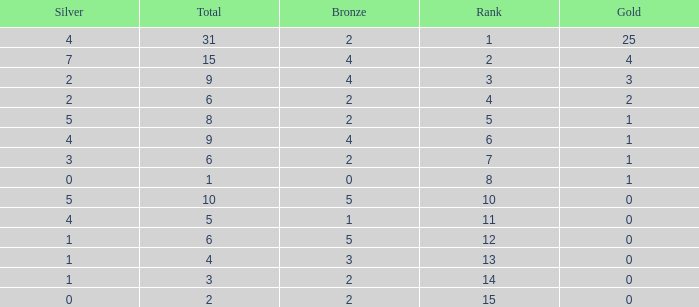What is the highest rank of the medal total less than 15, more than 2 bronzes, 0 gold and 1 silver? 13.0. 